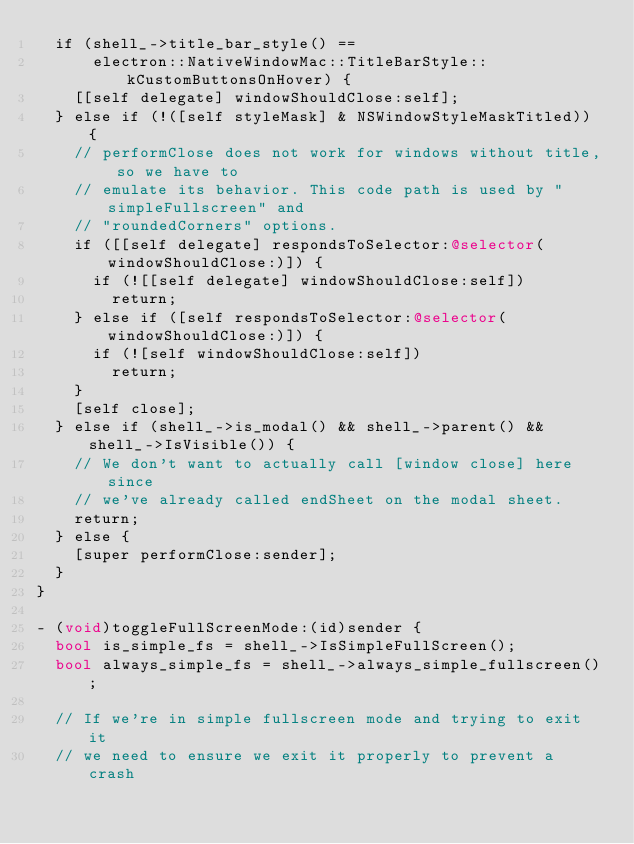Convert code to text. <code><loc_0><loc_0><loc_500><loc_500><_ObjectiveC_>  if (shell_->title_bar_style() ==
      electron::NativeWindowMac::TitleBarStyle::kCustomButtonsOnHover) {
    [[self delegate] windowShouldClose:self];
  } else if (!([self styleMask] & NSWindowStyleMaskTitled)) {
    // performClose does not work for windows without title, so we have to
    // emulate its behavior. This code path is used by "simpleFullscreen" and
    // "roundedCorners" options.
    if ([[self delegate] respondsToSelector:@selector(windowShouldClose:)]) {
      if (![[self delegate] windowShouldClose:self])
        return;
    } else if ([self respondsToSelector:@selector(windowShouldClose:)]) {
      if (![self windowShouldClose:self])
        return;
    }
    [self close];
  } else if (shell_->is_modal() && shell_->parent() && shell_->IsVisible()) {
    // We don't want to actually call [window close] here since
    // we've already called endSheet on the modal sheet.
    return;
  } else {
    [super performClose:sender];
  }
}

- (void)toggleFullScreenMode:(id)sender {
  bool is_simple_fs = shell_->IsSimpleFullScreen();
  bool always_simple_fs = shell_->always_simple_fullscreen();

  // If we're in simple fullscreen mode and trying to exit it
  // we need to ensure we exit it properly to prevent a crash</code> 